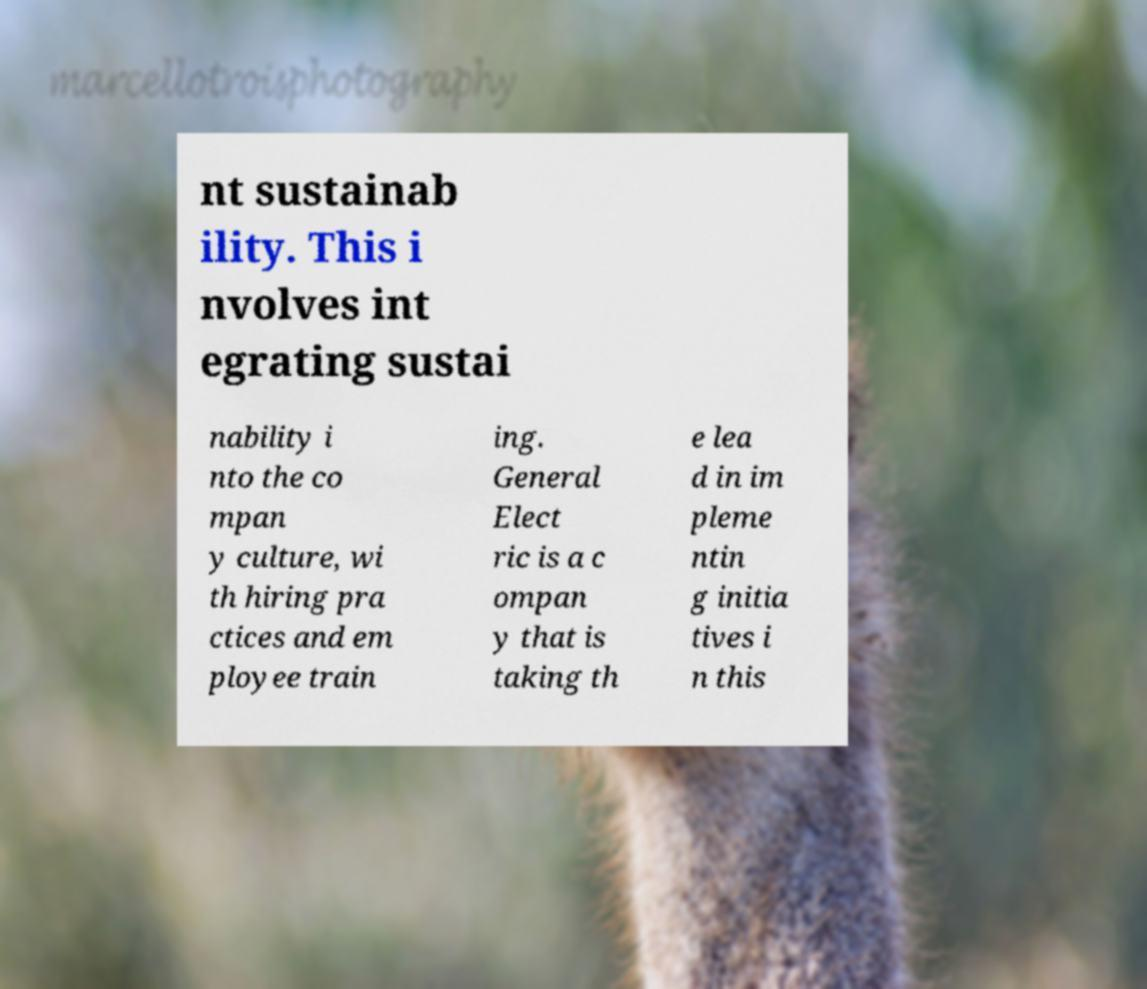What messages or text are displayed in this image? I need them in a readable, typed format. nt sustainab ility. This i nvolves int egrating sustai nability i nto the co mpan y culture, wi th hiring pra ctices and em ployee train ing. General Elect ric is a c ompan y that is taking th e lea d in im pleme ntin g initia tives i n this 